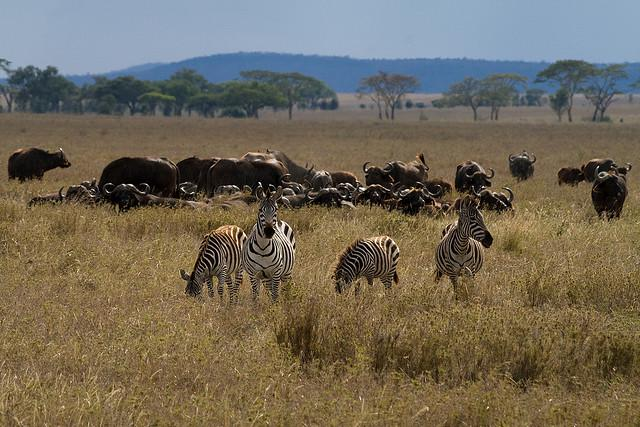How many zebras are standing in front of the pack of buffalo?

Choices:
A) three
B) four
C) five
D) two four 